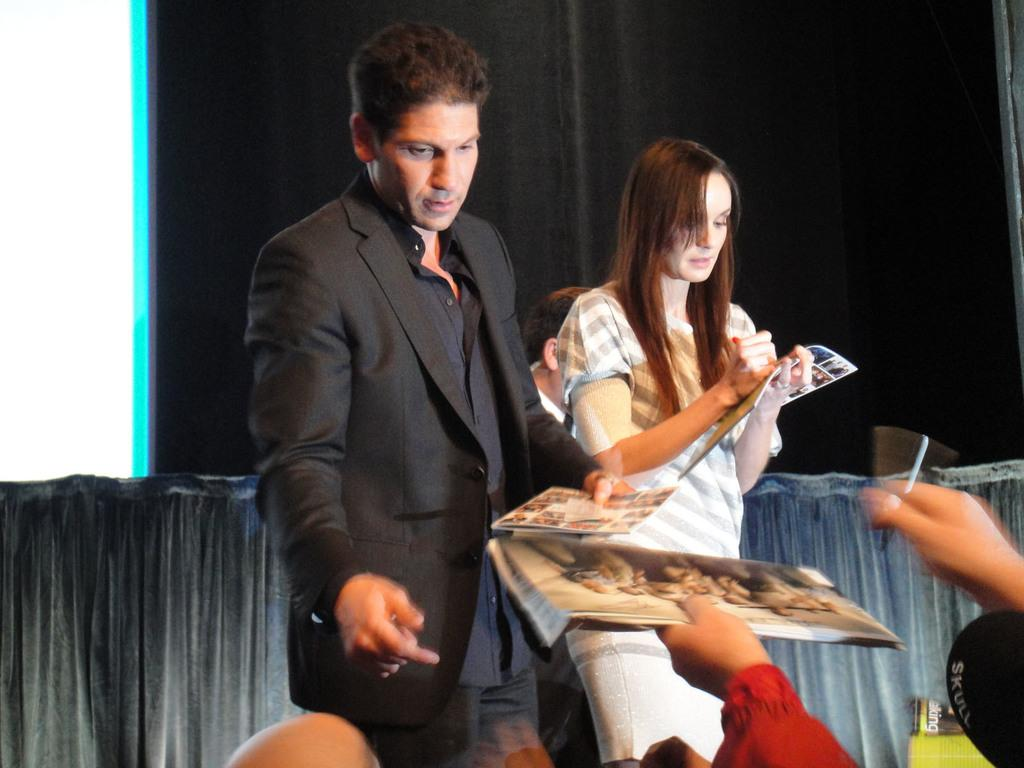How many people are in the image? There are two people in the image, a man and a woman. What are the man and the woman doing in the image? Both the man and the woman are standing and holding books. Can you describe any additional objects in the image? There are hands holding a book and a pen in the image. What can be seen in the background of the image? There are curtains in the background of the image. What type of hill can be seen in the background of the image? There is no hill present in the image; the background features curtains. Are the man and the woman wearing matching trousers in the image? The provided facts do not mention the clothing of the man and the woman, so it cannot be determined if they are wearing matching trousers. 